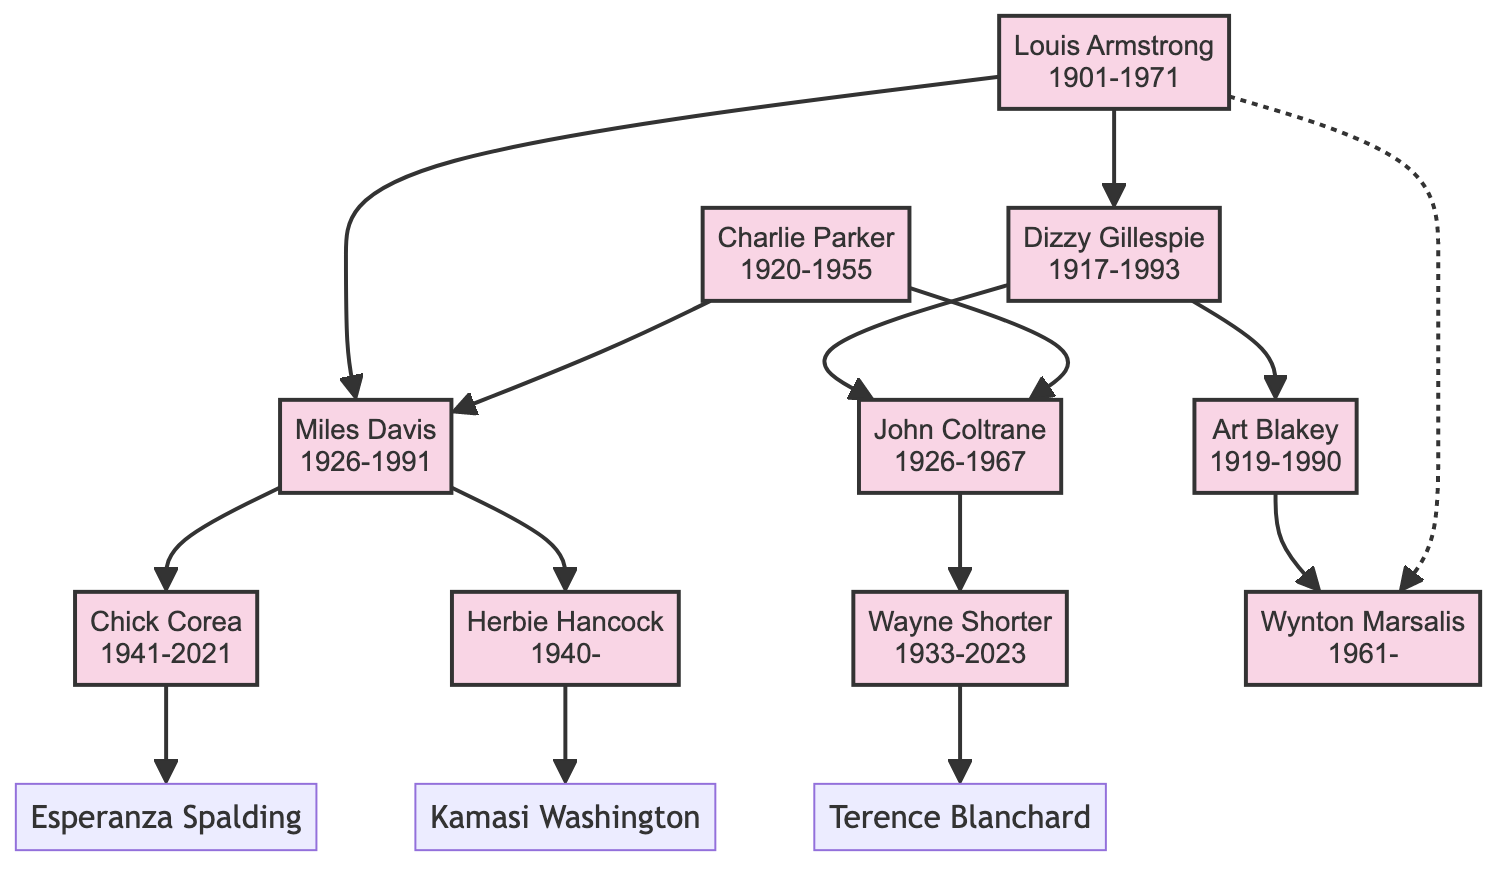What year was Louis Armstrong born? Louis Armstrong is listed in the diagram with the birth year shown directly under his name. The year is 1901.
Answer: 1901 Who did Dizzy Gillespie influence? The diagram indicates that Dizzy Gillespie influenced two musicians: John Coltrane and Art Blakey, shown directly under his name.
Answer: John Coltrane, Art Blakey How many musicians are shown in the diagram? To find the number of musicians, we can count each distinct name in the family tree. There are ten musicians listed.
Answer: 10 Which musician influenced Wynton Marsalis? The diagram indicates that Wynton Marsalis was influenced by Louis Armstrong and Art Blakey, as seen by the arrows pointing to him.
Answer: Louis Armstrong, Art Blakey Who directly influenced Herbie Hancock? The name directly preceding Herbie Hancock in the diagram is Miles Davis, showing that he had a direct influence on Hancock.
Answer: Miles Davis Name a musician influenced by John Coltrane. The diagram shows that Wayne Shorter is influenced by John Coltrane, as indicated by the directed edge connecting the two musicians.
Answer: Wayne Shorter Which musician can be traced back to both Louis Armstrong and Art Blakey? To determine this, you trace the influence from Louis Armstrong (who influenced Dizzy Gillespie) onward to Wynton Marsalis, who is influenced by both Armstrong and Art Blakey.
Answer: Wynton Marsalis Who was influenced by Charlie Parker? The diagram lists Miles Davis and John Coltrane as being influenced by Charlie Parker, shown by arrows leading from Parker to both musicians.
Answer: Miles Davis, John Coltrane Which musician did not influence anyone? Looking at the diagram, Wynton Marsalis does not have any outgoing edges, signifying he did not influence anyone directly.
Answer: Wynton Marsalis 